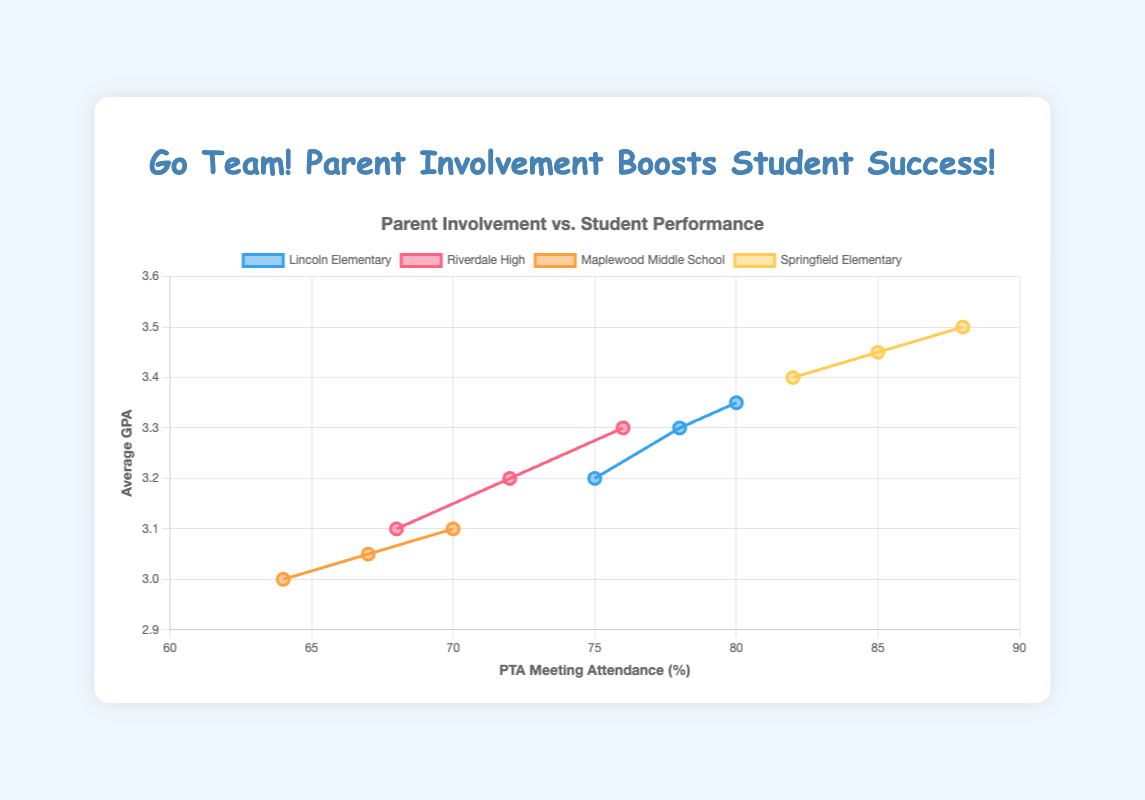What trend do you observe for PTA meeting attendance and average GPA at Lincoln Elementary between 2018 and 2020? From 2018 to 2020, PTA meeting attendance increased from 75% to 80%, and the average GPA increased from 3.2 to 3.35. Both metrics show an upward trend.
Answer: Both increased Comparing Springfield Elementary and Riverdale High, which school had a higher PTA meeting attendance and average GPA in 2020? In 2020, Springfield Elementary had a PTA meeting attendance of 88% and an average GPA of 3.5, while Riverdale High had a PTA meeting attendance of 76% and an average GPA of 3.3. Springfield Elementary had higher values in both metrics.
Answer: Springfield Elementary Which school had the lowest PTA meeting attendance in 2018? Maplewood Middle School had the lowest PTA meeting attendance in 2018 at 64%.
Answer: Maplewood Middle School By how much did the average GPA increase at Riverdale High from 2018 to 2020? The average GPA at Riverdale High increased from 3.1 in 2018 to 3.3 in 2020. The increase is 0.2 (3.3 - 3.1).
Answer: 0.2 How does the relationship between PTA meeting attendance and average GPA change for Maplewood Middle School from 2018 to 2020? Maplewood Middle School showed an increase in both PTA meeting attendance (from 64% to 70%) and average GPA (from 3.0 to 3.1) between 2018 and 2020. This suggests a positive correlation between PTA meeting attendance and average GPA over these years.
Answer: Positive correlation What is the average PTA meeting attendance across all schools in 2020? To find the average, add the PTA meeting attendance percentages for all schools in 2020: (80 + 76 + 70 + 88), which equals 314. Divide by the number of schools, which is 4. 314/4 = 78.5%.
Answer: 78.5% Which school showed the largest increase in volunteer hours per student from 2018 to 2020? Springfield Elementary showed an increase in volunteer hours per student from 15 in 2018 to 19 in 2020. The increase is 4 hours. Comparing with other schools, it shows the largest increase.
Answer: Springfield Elementary What was the pattern of the relationship between PTA meeting attendance and average GPA for Springfield Elementary? For Springfield Elementary, both PTA meeting attendance and average GPA increased consistently from 2018 to 2020. PTA meeting attendance went from 82% in 2018 to 88% in 2020, while the average GPA went from 3.4 to 3.5 during the same period, indicating a positive correlation.
Answer: Positive correlation How did the average GPA at Lincoln Elementary change from 2018 to 2019 compared to 2019 to 2020? From 2018 to 2019, the average GPA at Lincoln Elementary increased from 3.2 to 3.3, an increase of 0.1. From 2019 to 2020, the average GPA increased from 3.3 to 3.35, an increase of 0.05. So, the increase was larger from 2018 to 2019.
Answer: Larger increase from 2018 to 2019 